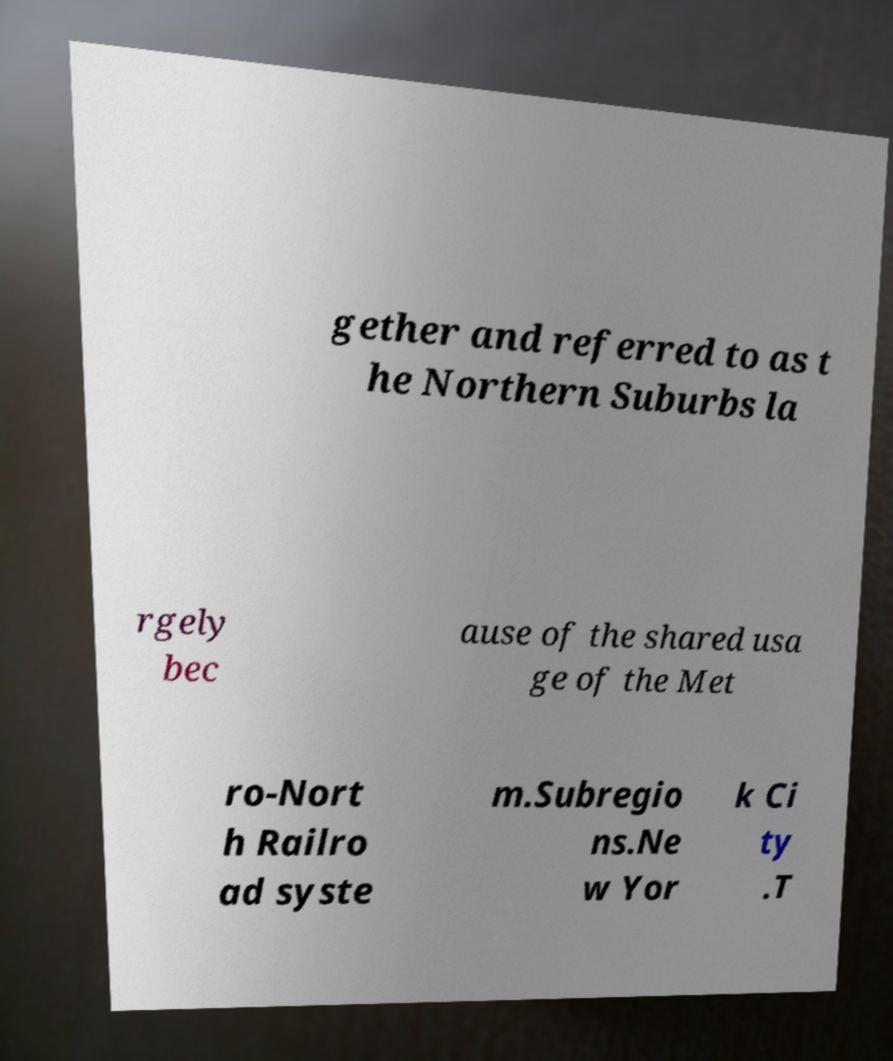What messages or text are displayed in this image? I need them in a readable, typed format. gether and referred to as t he Northern Suburbs la rgely bec ause of the shared usa ge of the Met ro-Nort h Railro ad syste m.Subregio ns.Ne w Yor k Ci ty .T 